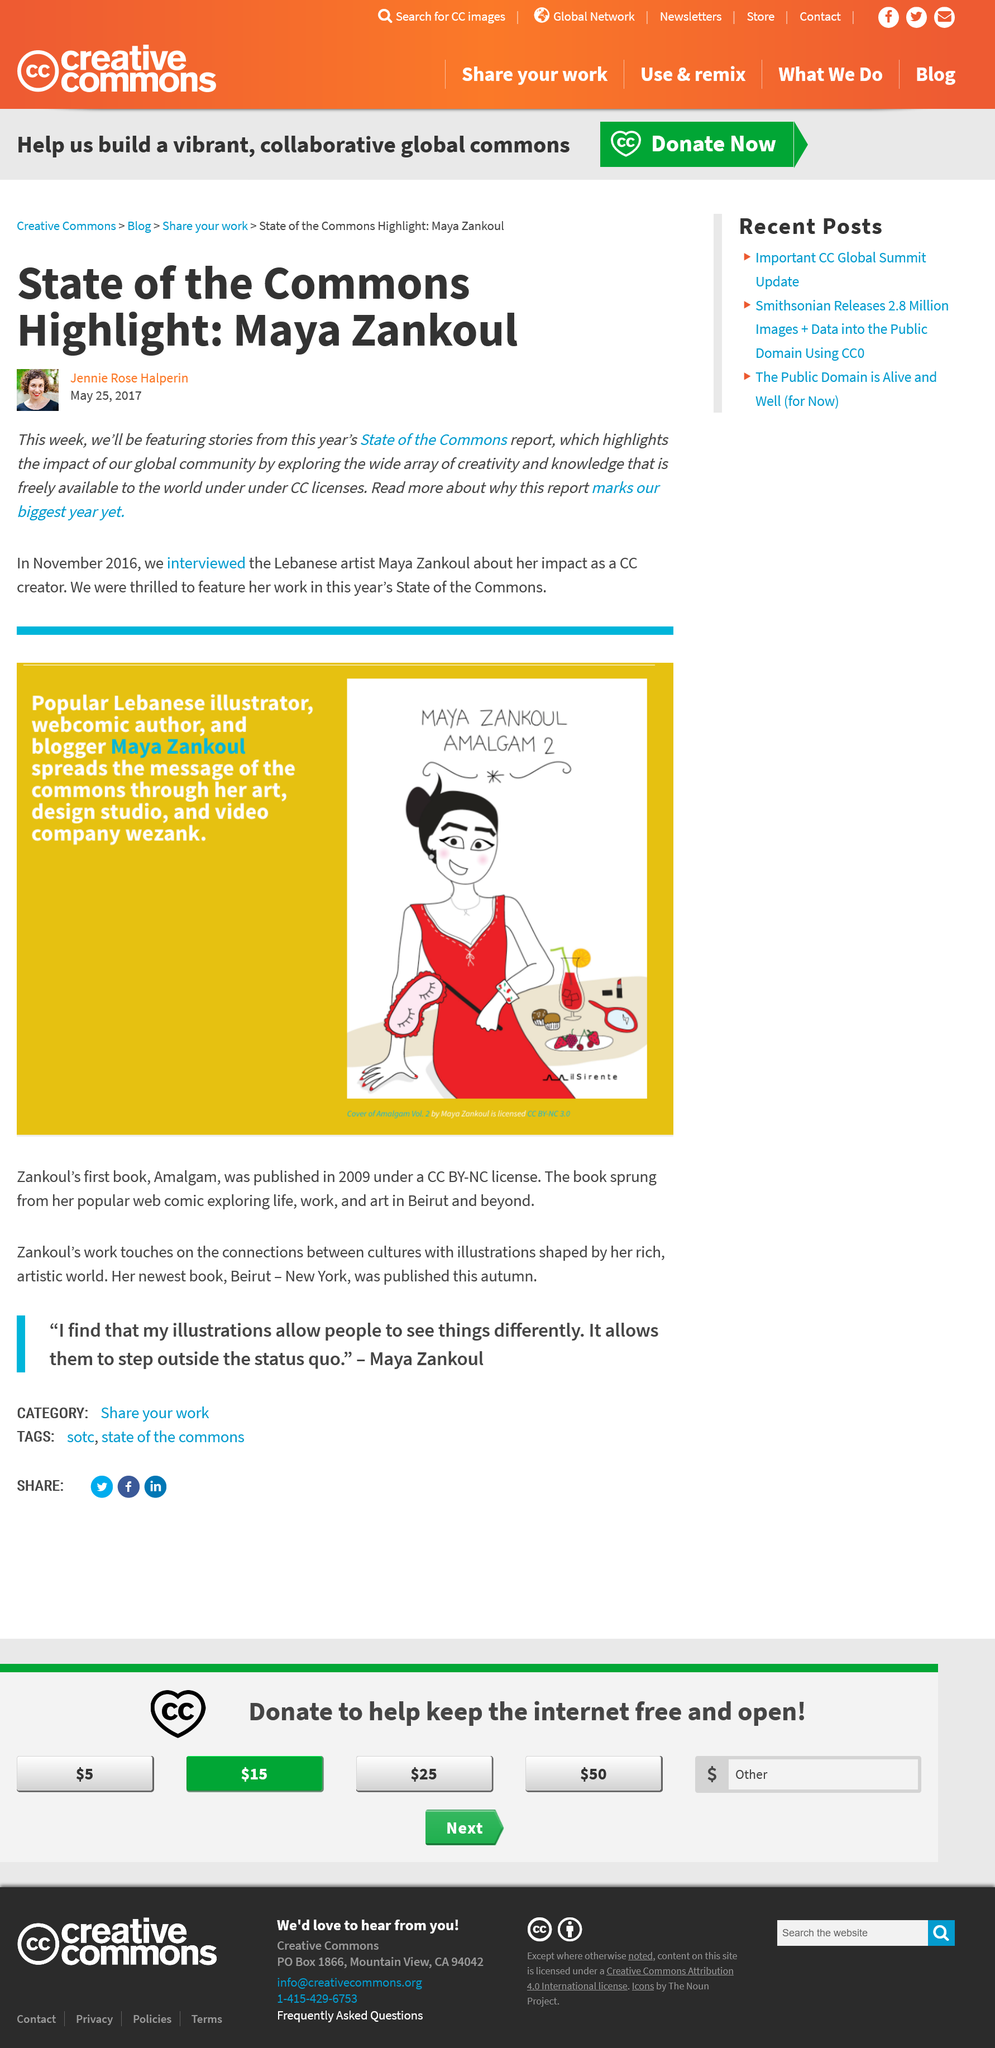Highlight a few significant elements in this photo. Maya is from Lebanon. Maya Zankoul is the highlight of the state of the commons. Maya Zankoul is an artist who possesses the profession of being an artist. 